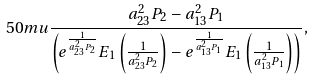<formula> <loc_0><loc_0><loc_500><loc_500>{ 5 0 m u } \frac { a _ { 2 3 } ^ { 2 } P _ { 2 } - a _ { 1 3 } ^ { 2 } P _ { 1 } } { \left ( e ^ { \frac { 1 } { a _ { 2 3 } ^ { 2 } P _ { 2 } } } E _ { 1 } \left ( \frac { 1 } { a _ { 2 3 } ^ { 2 } P _ { 2 } } \right ) - e ^ { \frac { 1 } { a _ { 1 3 } ^ { 2 } P _ { 1 } } } E _ { 1 } \left ( \frac { 1 } { a _ { 1 3 } ^ { 2 } P _ { 1 } } \right ) \right ) } ,</formula> 